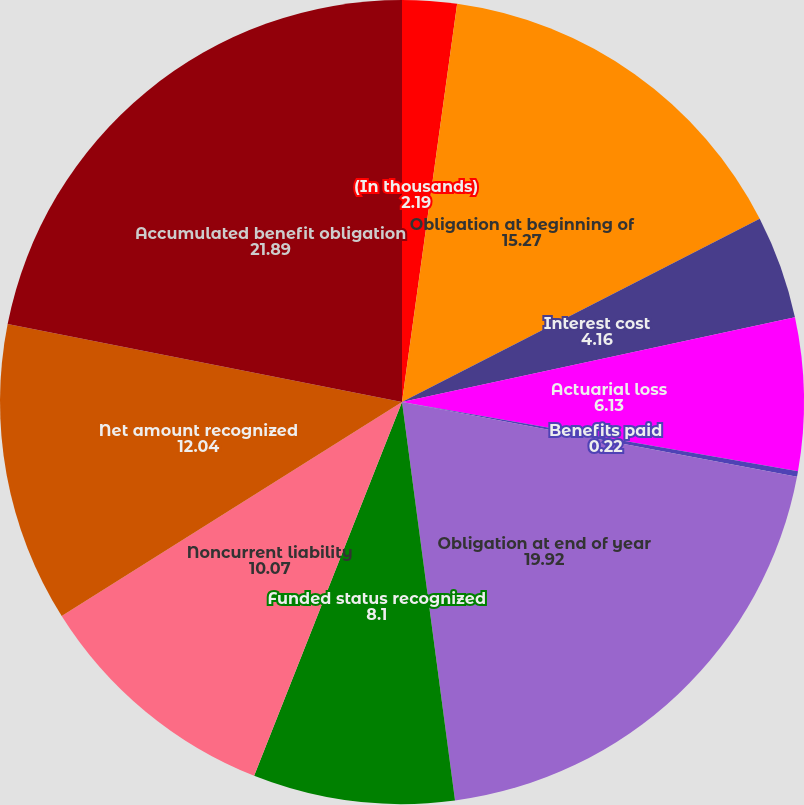<chart> <loc_0><loc_0><loc_500><loc_500><pie_chart><fcel>(In thousands)<fcel>Obligation at beginning of<fcel>Interest cost<fcel>Actuarial loss<fcel>Benefits paid<fcel>Obligation at end of year<fcel>Funded status recognized<fcel>Noncurrent liability<fcel>Net amount recognized<fcel>Accumulated benefit obligation<nl><fcel>2.19%<fcel>15.27%<fcel>4.16%<fcel>6.13%<fcel>0.22%<fcel>19.92%<fcel>8.1%<fcel>10.07%<fcel>12.04%<fcel>21.89%<nl></chart> 